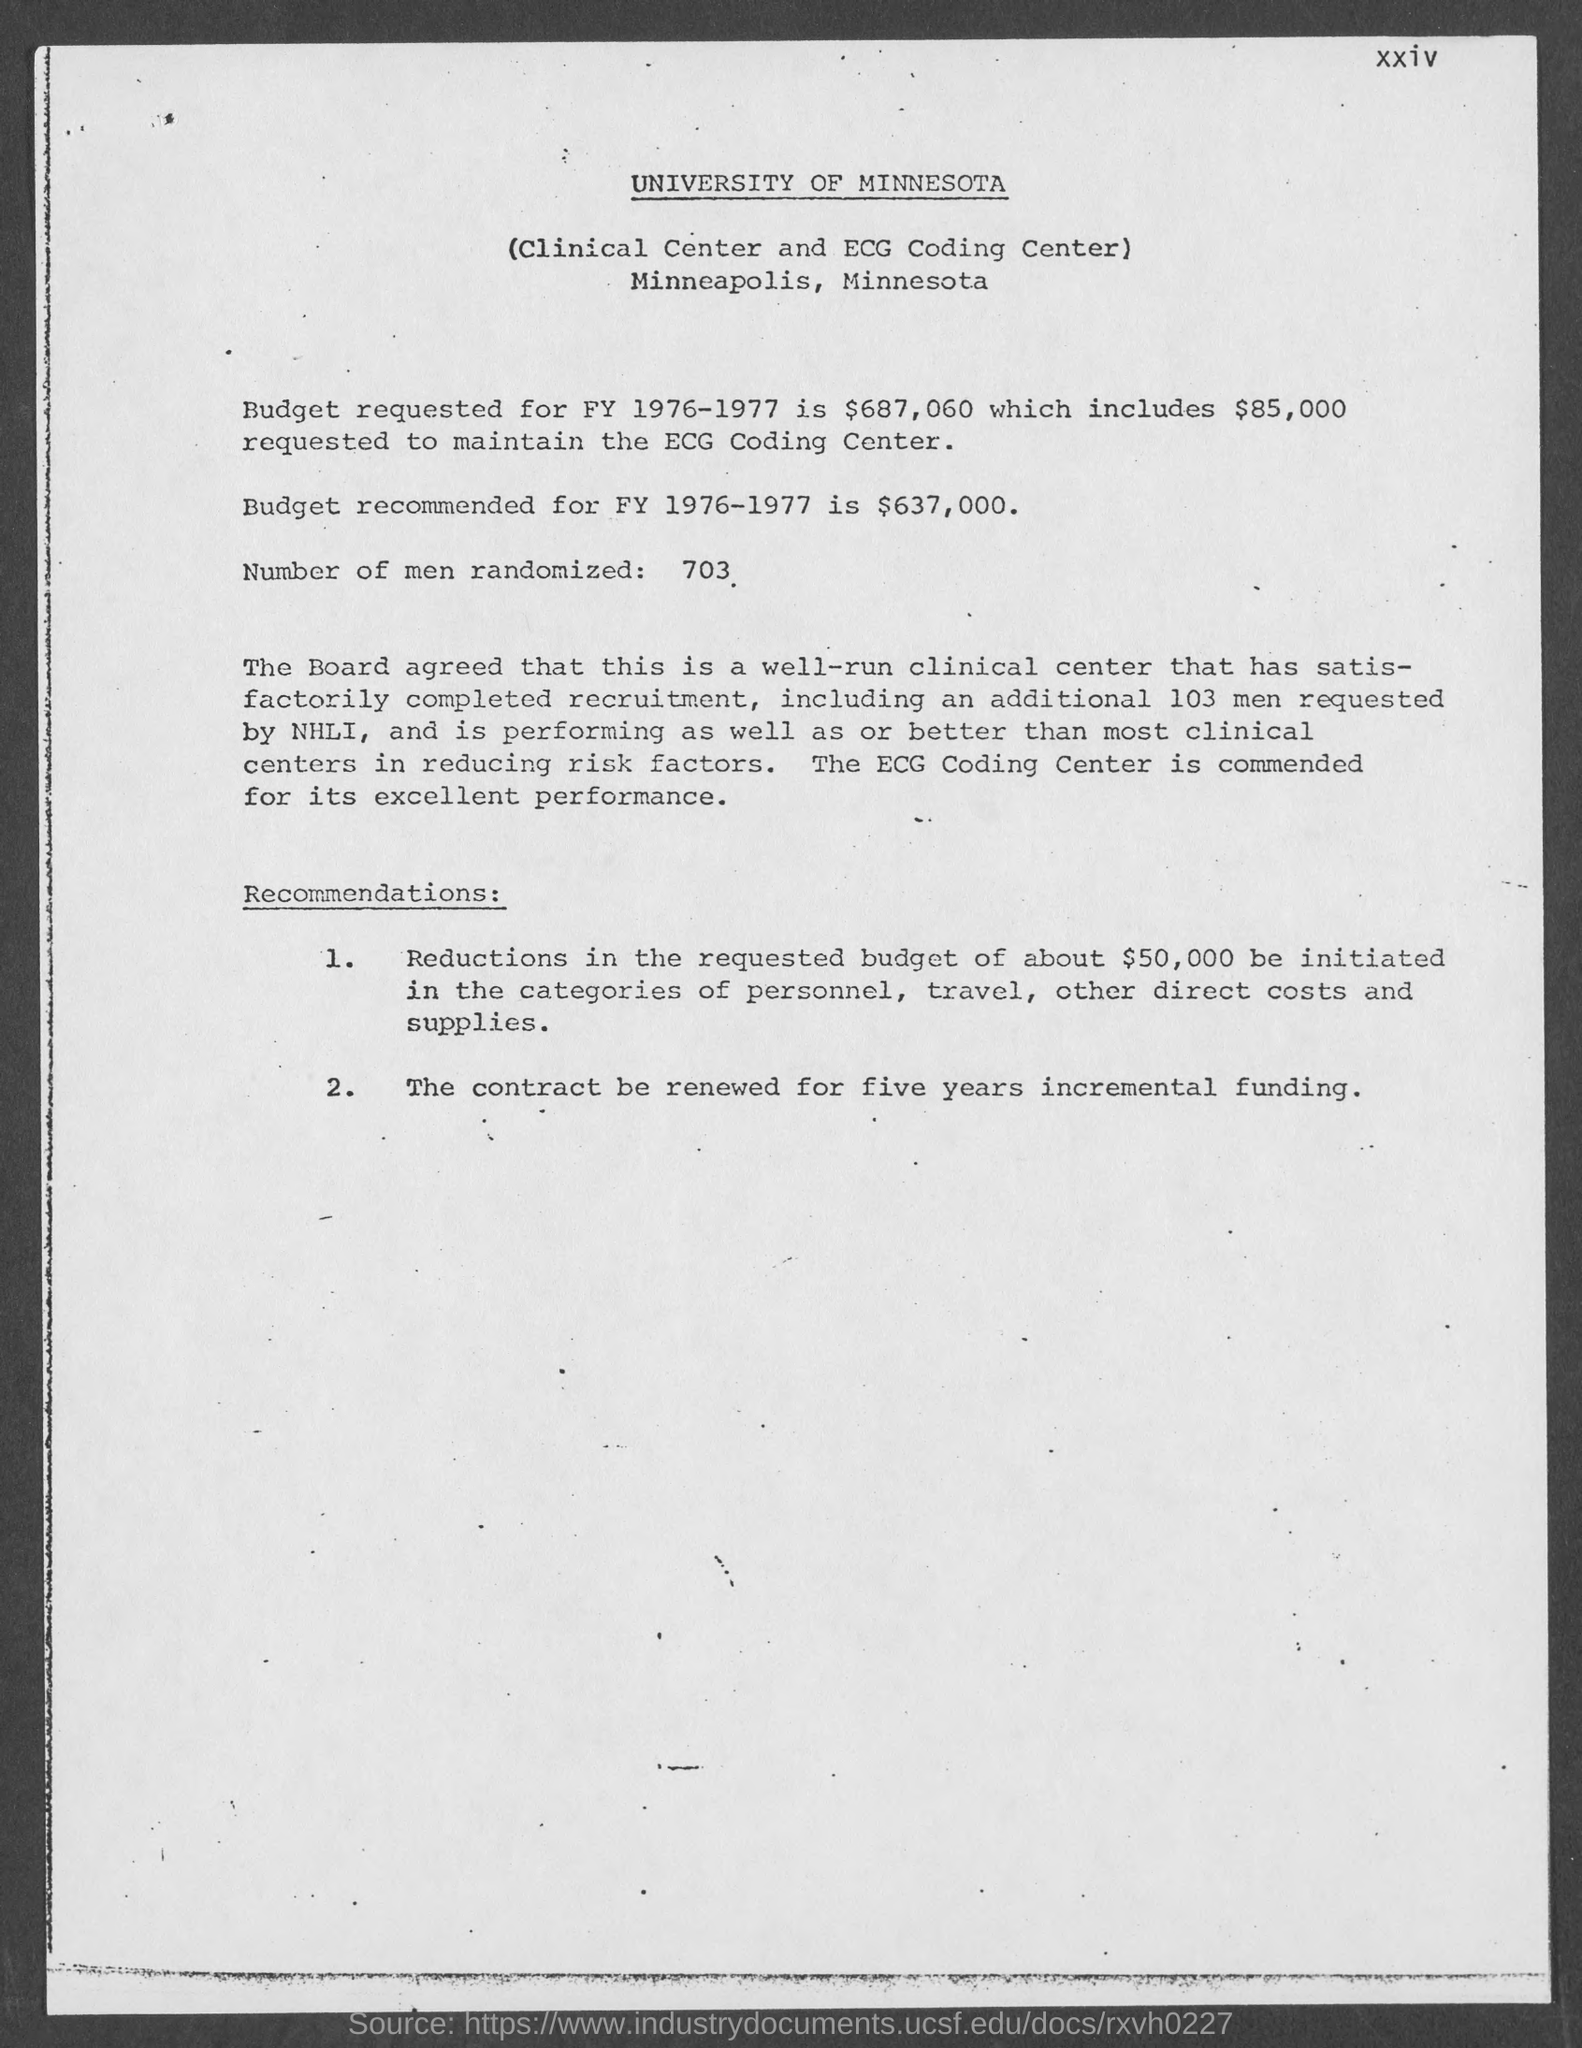List a handful of essential elements in this visual. The header of the document mentions the University of Minnesota. The document reports the randomization of 703 men. 